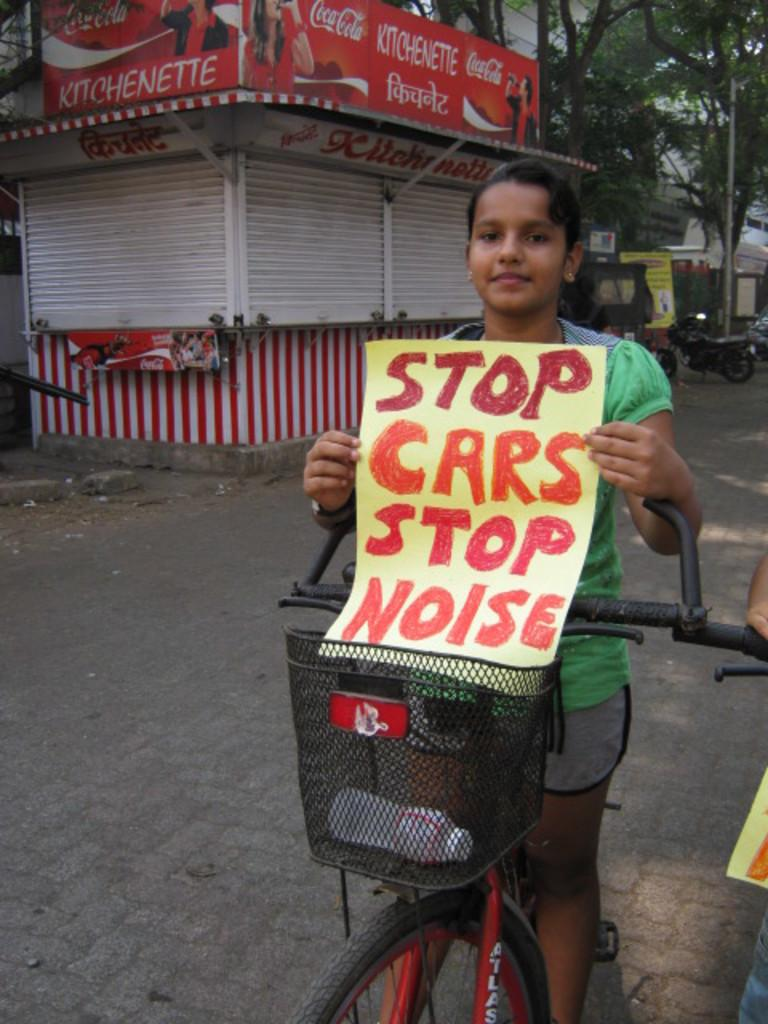What are the girls doing in the image? The girls are sitting on a cycle in the image. What are the girls holding in the image? The girls are holding a paper in the image. What can be seen in the background of the image? There are buildings, trees, and bikes in the background of the image. What type of poison is the girls using to ride the cycle in the image? There is no poison present in the image, and the girls are not using any poison to ride the cycle. 